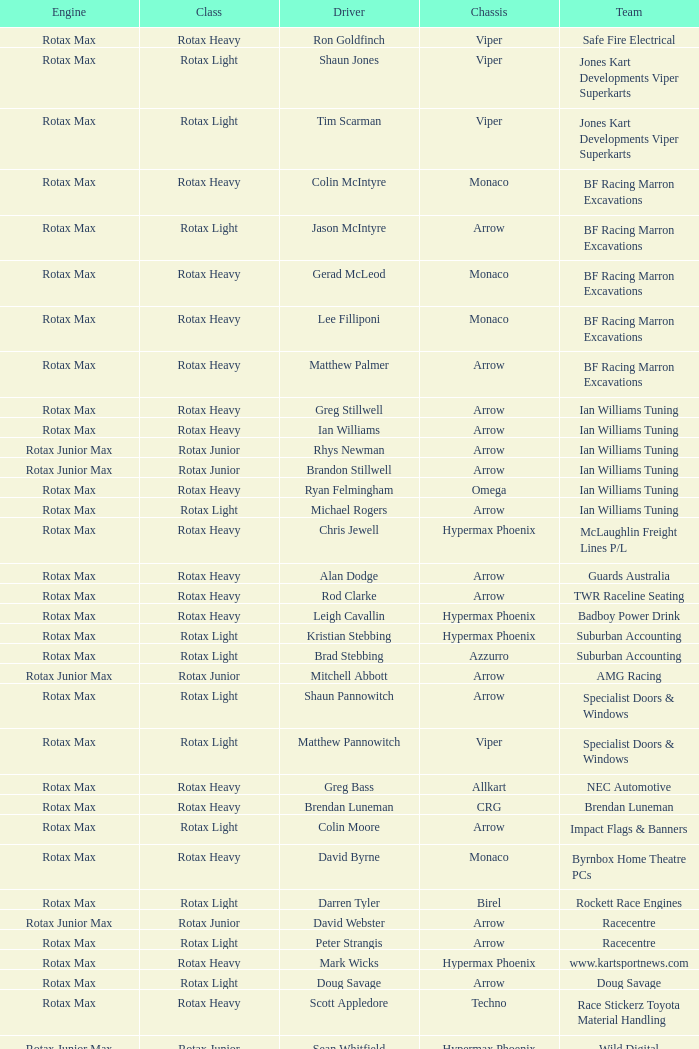Driver Shaun Jones with a viper as a chassis is in what class? Rotax Light. 